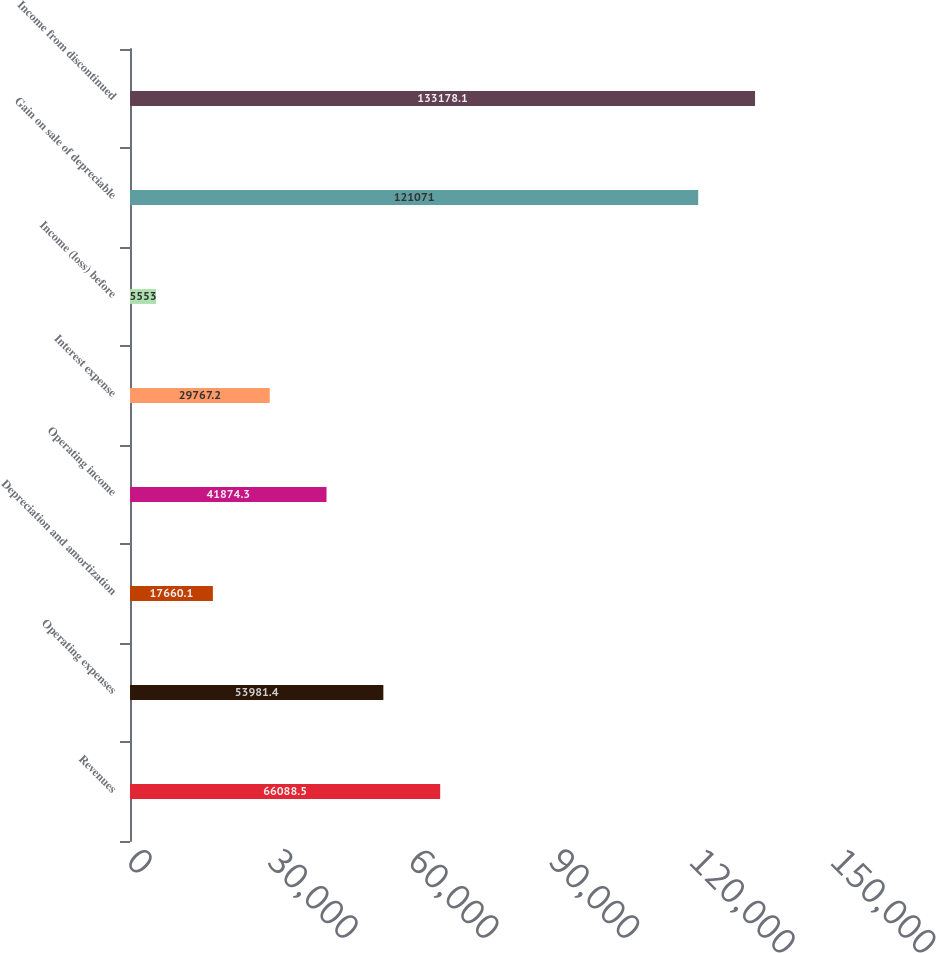Convert chart to OTSL. <chart><loc_0><loc_0><loc_500><loc_500><bar_chart><fcel>Revenues<fcel>Operating expenses<fcel>Depreciation and amortization<fcel>Operating income<fcel>Interest expense<fcel>Income (loss) before<fcel>Gain on sale of depreciable<fcel>Income from discontinued<nl><fcel>66088.5<fcel>53981.4<fcel>17660.1<fcel>41874.3<fcel>29767.2<fcel>5553<fcel>121071<fcel>133178<nl></chart> 